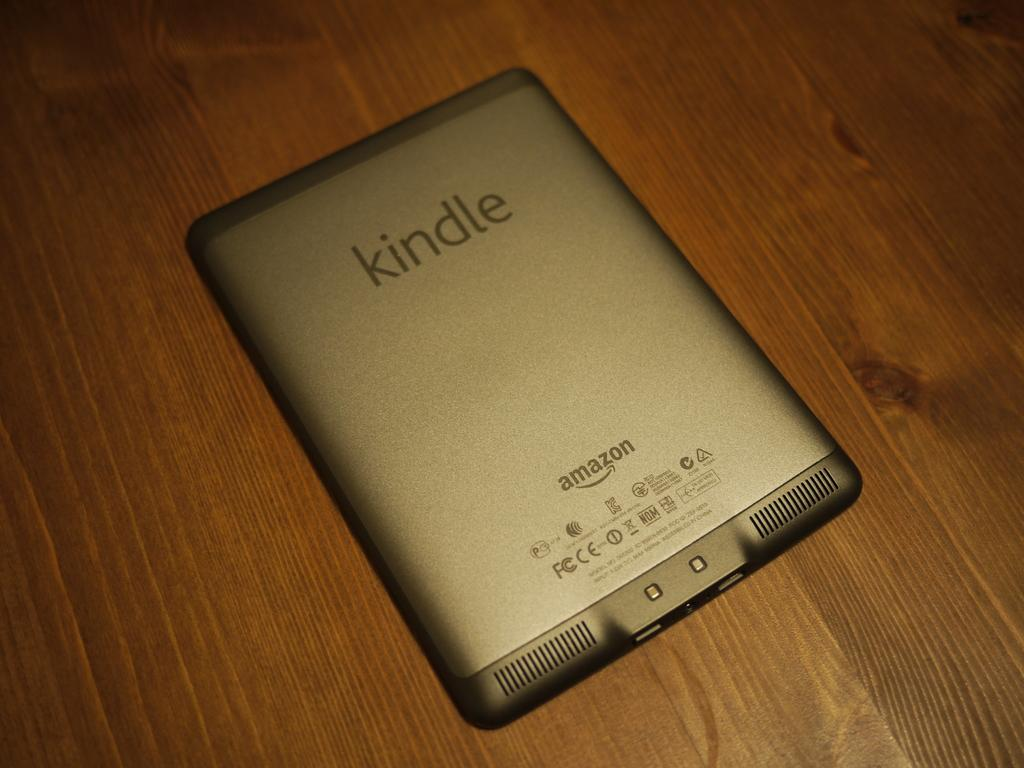<image>
Provide a brief description of the given image. An Amazon Kindle sitting face down on a table. 